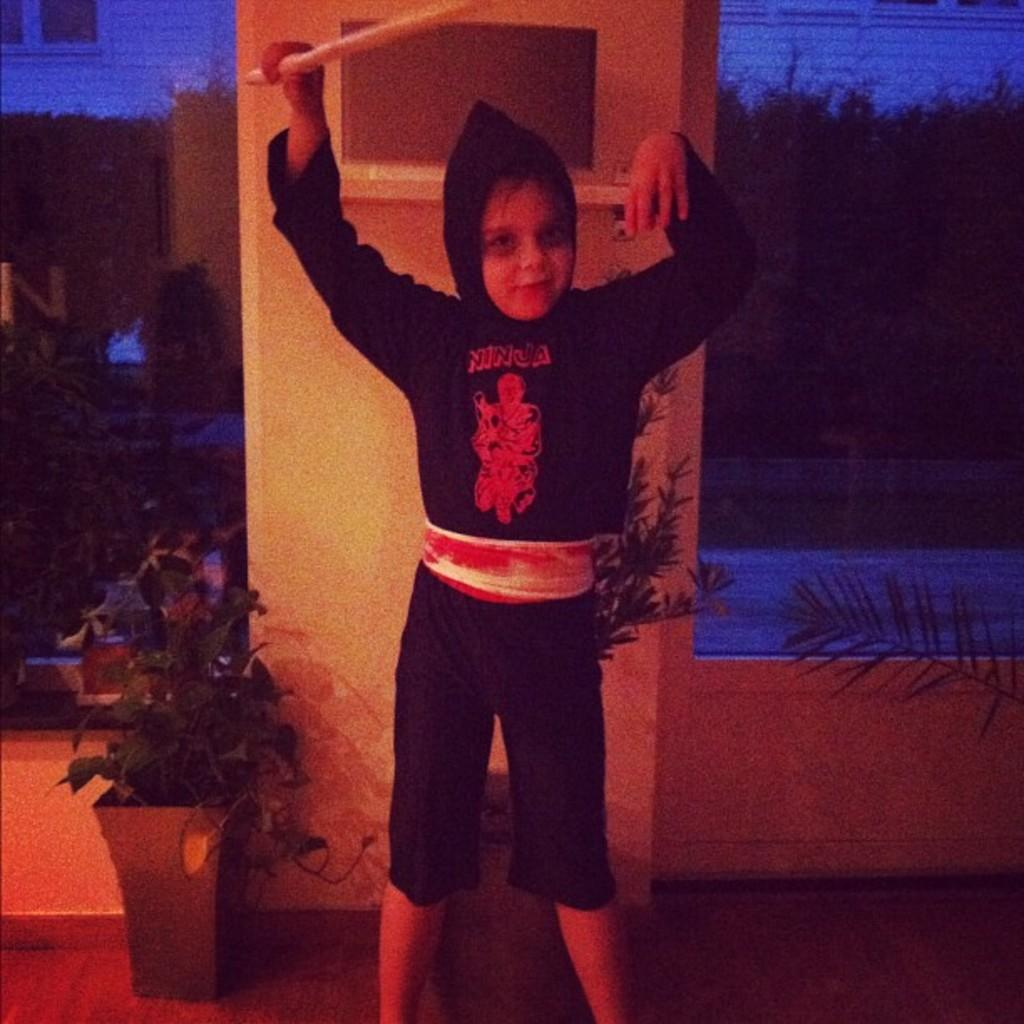What is the main subject of the image? There is a child in the image. Where is the child positioned in the image? The child is standing on the floor. What can be seen in the background of the image? There are buildings, trees, and house plants in the background of the image. Can you tell me how many airplanes are flying in the image? There are no airplanes visible in the image. What type of respect is being shown by the child in the image? There is no indication of respect being shown by the child in the image. 